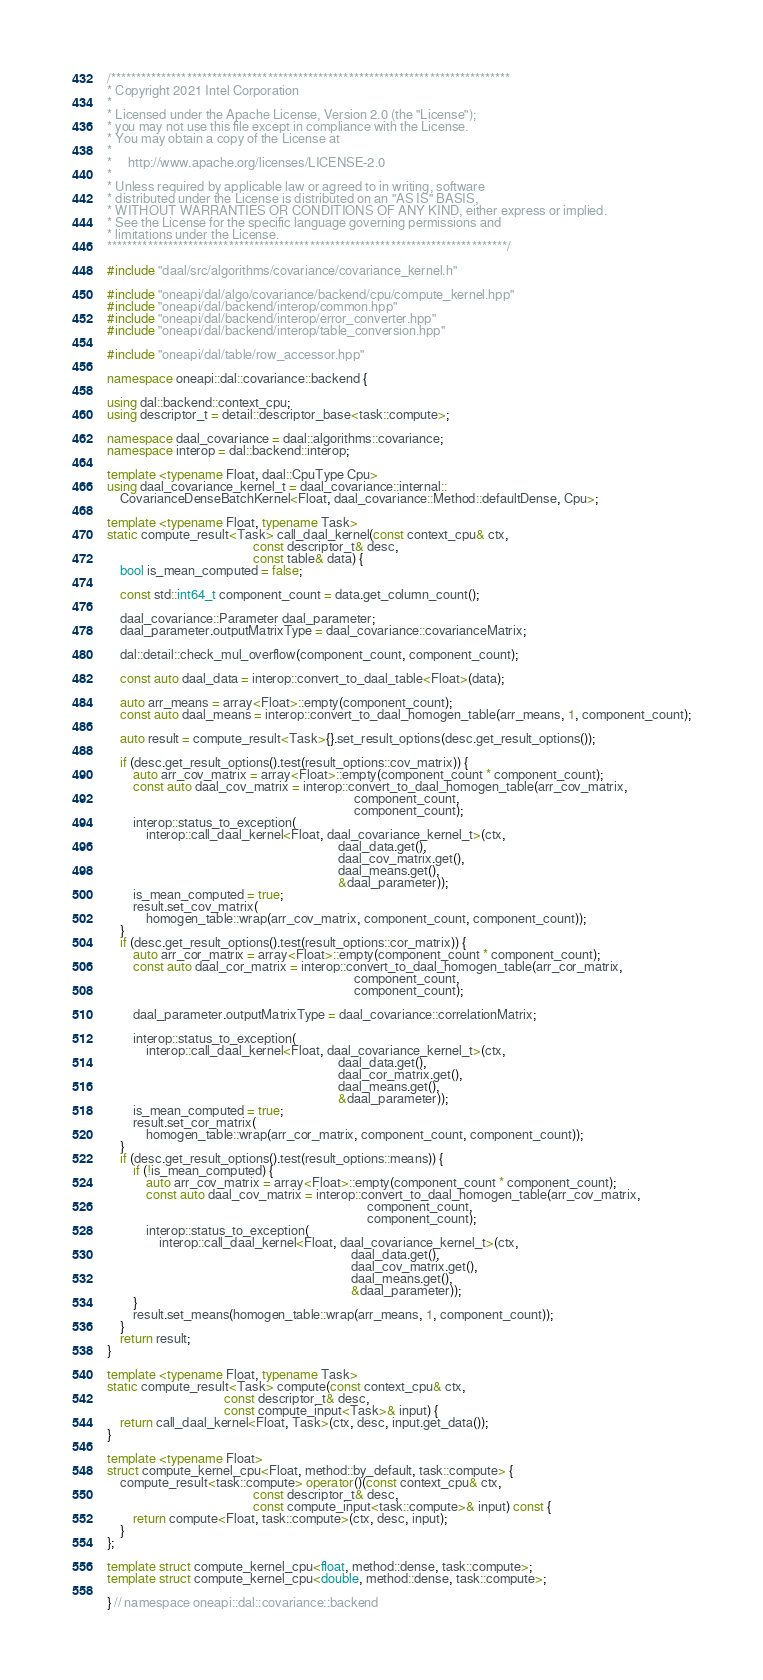<code> <loc_0><loc_0><loc_500><loc_500><_C++_>/*******************************************************************************
* Copyright 2021 Intel Corporation
*
* Licensed under the Apache License, Version 2.0 (the "License");
* you may not use this file except in compliance with the License.
* You may obtain a copy of the License at
*
*     http://www.apache.org/licenses/LICENSE-2.0
*
* Unless required by applicable law or agreed to in writing, software
* distributed under the License is distributed on an "AS IS" BASIS,
* WITHOUT WARRANTIES OR CONDITIONS OF ANY KIND, either express or implied.
* See the License for the specific language governing permissions and
* limitations under the License.
*******************************************************************************/

#include "daal/src/algorithms/covariance/covariance_kernel.h"

#include "oneapi/dal/algo/covariance/backend/cpu/compute_kernel.hpp"
#include "oneapi/dal/backend/interop/common.hpp"
#include "oneapi/dal/backend/interop/error_converter.hpp"
#include "oneapi/dal/backend/interop/table_conversion.hpp"

#include "oneapi/dal/table/row_accessor.hpp"

namespace oneapi::dal::covariance::backend {

using dal::backend::context_cpu;
using descriptor_t = detail::descriptor_base<task::compute>;

namespace daal_covariance = daal::algorithms::covariance;
namespace interop = dal::backend::interop;

template <typename Float, daal::CpuType Cpu>
using daal_covariance_kernel_t = daal_covariance::internal::
    CovarianceDenseBatchKernel<Float, daal_covariance::Method::defaultDense, Cpu>;

template <typename Float, typename Task>
static compute_result<Task> call_daal_kernel(const context_cpu& ctx,
                                             const descriptor_t& desc,
                                             const table& data) {
    bool is_mean_computed = false;

    const std::int64_t component_count = data.get_column_count();

    daal_covariance::Parameter daal_parameter;
    daal_parameter.outputMatrixType = daal_covariance::covarianceMatrix;

    dal::detail::check_mul_overflow(component_count, component_count);

    const auto daal_data = interop::convert_to_daal_table<Float>(data);

    auto arr_means = array<Float>::empty(component_count);
    const auto daal_means = interop::convert_to_daal_homogen_table(arr_means, 1, component_count);

    auto result = compute_result<Task>{}.set_result_options(desc.get_result_options());

    if (desc.get_result_options().test(result_options::cov_matrix)) {
        auto arr_cov_matrix = array<Float>::empty(component_count * component_count);
        const auto daal_cov_matrix = interop::convert_to_daal_homogen_table(arr_cov_matrix,
                                                                            component_count,
                                                                            component_count);
        interop::status_to_exception(
            interop::call_daal_kernel<Float, daal_covariance_kernel_t>(ctx,
                                                                       daal_data.get(),
                                                                       daal_cov_matrix.get(),
                                                                       daal_means.get(),
                                                                       &daal_parameter));
        is_mean_computed = true;
        result.set_cov_matrix(
            homogen_table::wrap(arr_cov_matrix, component_count, component_count));
    }
    if (desc.get_result_options().test(result_options::cor_matrix)) {
        auto arr_cor_matrix = array<Float>::empty(component_count * component_count);
        const auto daal_cor_matrix = interop::convert_to_daal_homogen_table(arr_cor_matrix,
                                                                            component_count,
                                                                            component_count);

        daal_parameter.outputMatrixType = daal_covariance::correlationMatrix;

        interop::status_to_exception(
            interop::call_daal_kernel<Float, daal_covariance_kernel_t>(ctx,
                                                                       daal_data.get(),
                                                                       daal_cor_matrix.get(),
                                                                       daal_means.get(),
                                                                       &daal_parameter));
        is_mean_computed = true;
        result.set_cor_matrix(
            homogen_table::wrap(arr_cor_matrix, component_count, component_count));
    }
    if (desc.get_result_options().test(result_options::means)) {
        if (!is_mean_computed) {
            auto arr_cov_matrix = array<Float>::empty(component_count * component_count);
            const auto daal_cov_matrix = interop::convert_to_daal_homogen_table(arr_cov_matrix,
                                                                                component_count,
                                                                                component_count);
            interop::status_to_exception(
                interop::call_daal_kernel<Float, daal_covariance_kernel_t>(ctx,
                                                                           daal_data.get(),
                                                                           daal_cov_matrix.get(),
                                                                           daal_means.get(),
                                                                           &daal_parameter));
        }
        result.set_means(homogen_table::wrap(arr_means, 1, component_count));
    }
    return result;
}

template <typename Float, typename Task>
static compute_result<Task> compute(const context_cpu& ctx,
                                    const descriptor_t& desc,
                                    const compute_input<Task>& input) {
    return call_daal_kernel<Float, Task>(ctx, desc, input.get_data());
}

template <typename Float>
struct compute_kernel_cpu<Float, method::by_default, task::compute> {
    compute_result<task::compute> operator()(const context_cpu& ctx,
                                             const descriptor_t& desc,
                                             const compute_input<task::compute>& input) const {
        return compute<Float, task::compute>(ctx, desc, input);
    }
};

template struct compute_kernel_cpu<float, method::dense, task::compute>;
template struct compute_kernel_cpu<double, method::dense, task::compute>;

} // namespace oneapi::dal::covariance::backend
</code> 